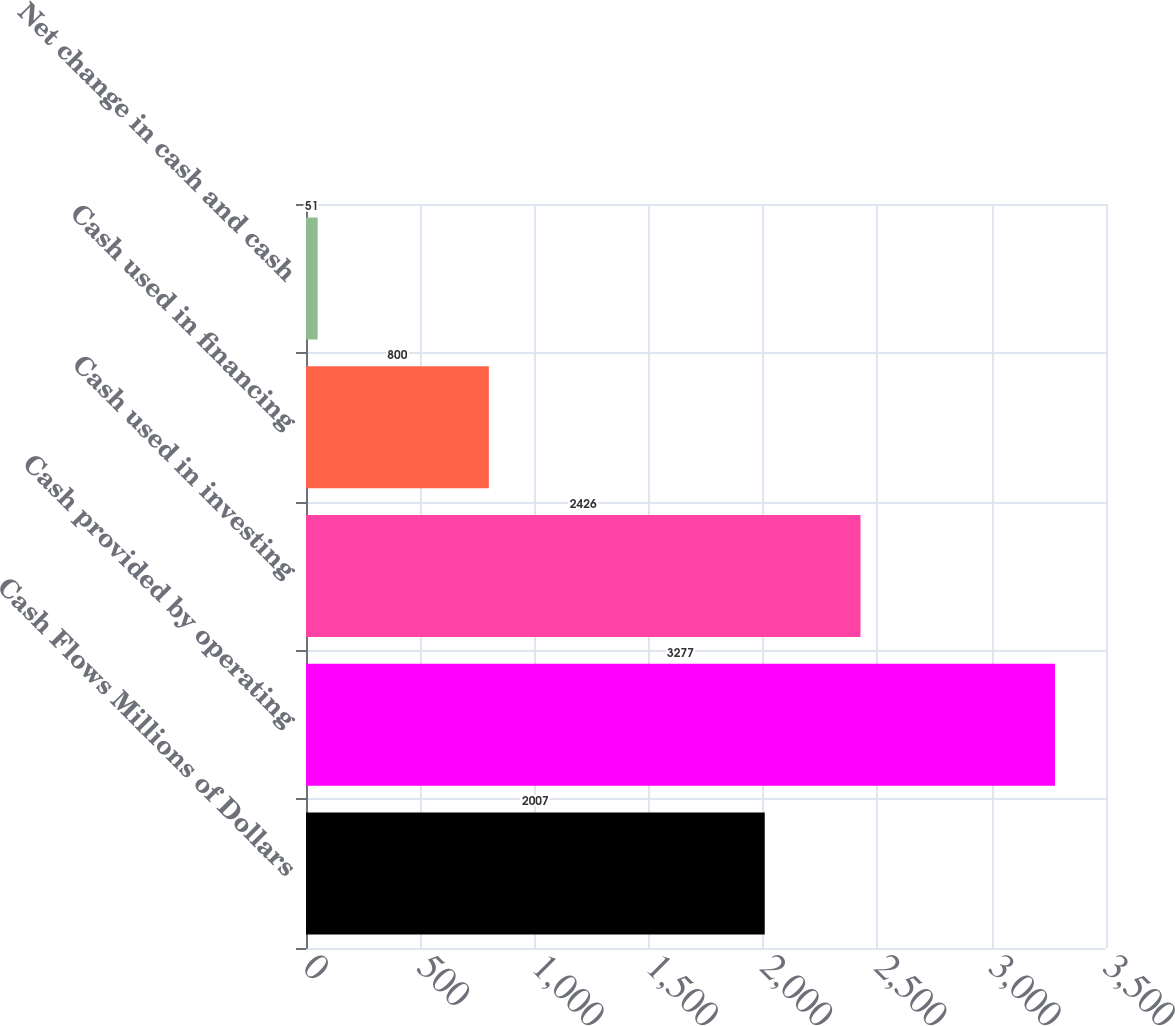Convert chart. <chart><loc_0><loc_0><loc_500><loc_500><bar_chart><fcel>Cash Flows Millions of Dollars<fcel>Cash provided by operating<fcel>Cash used in investing<fcel>Cash used in financing<fcel>Net change in cash and cash<nl><fcel>2007<fcel>3277<fcel>2426<fcel>800<fcel>51<nl></chart> 